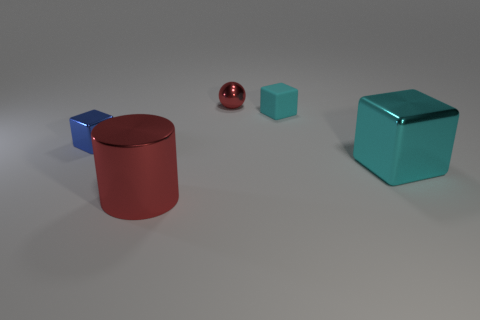Subtract all small cubes. How many cubes are left? 1 Add 1 big brown cylinders. How many objects exist? 6 Subtract 1 cubes. How many cubes are left? 2 Subtract all cyan blocks. How many blocks are left? 1 Subtract all cubes. How many objects are left? 2 Subtract all blue spheres. Subtract all yellow cylinders. How many spheres are left? 1 Subtract all green spheres. How many green cylinders are left? 0 Subtract all tiny shiny cubes. Subtract all tiny metallic things. How many objects are left? 2 Add 2 red metal cylinders. How many red metal cylinders are left? 3 Add 2 tiny cyan rubber cylinders. How many tiny cyan rubber cylinders exist? 2 